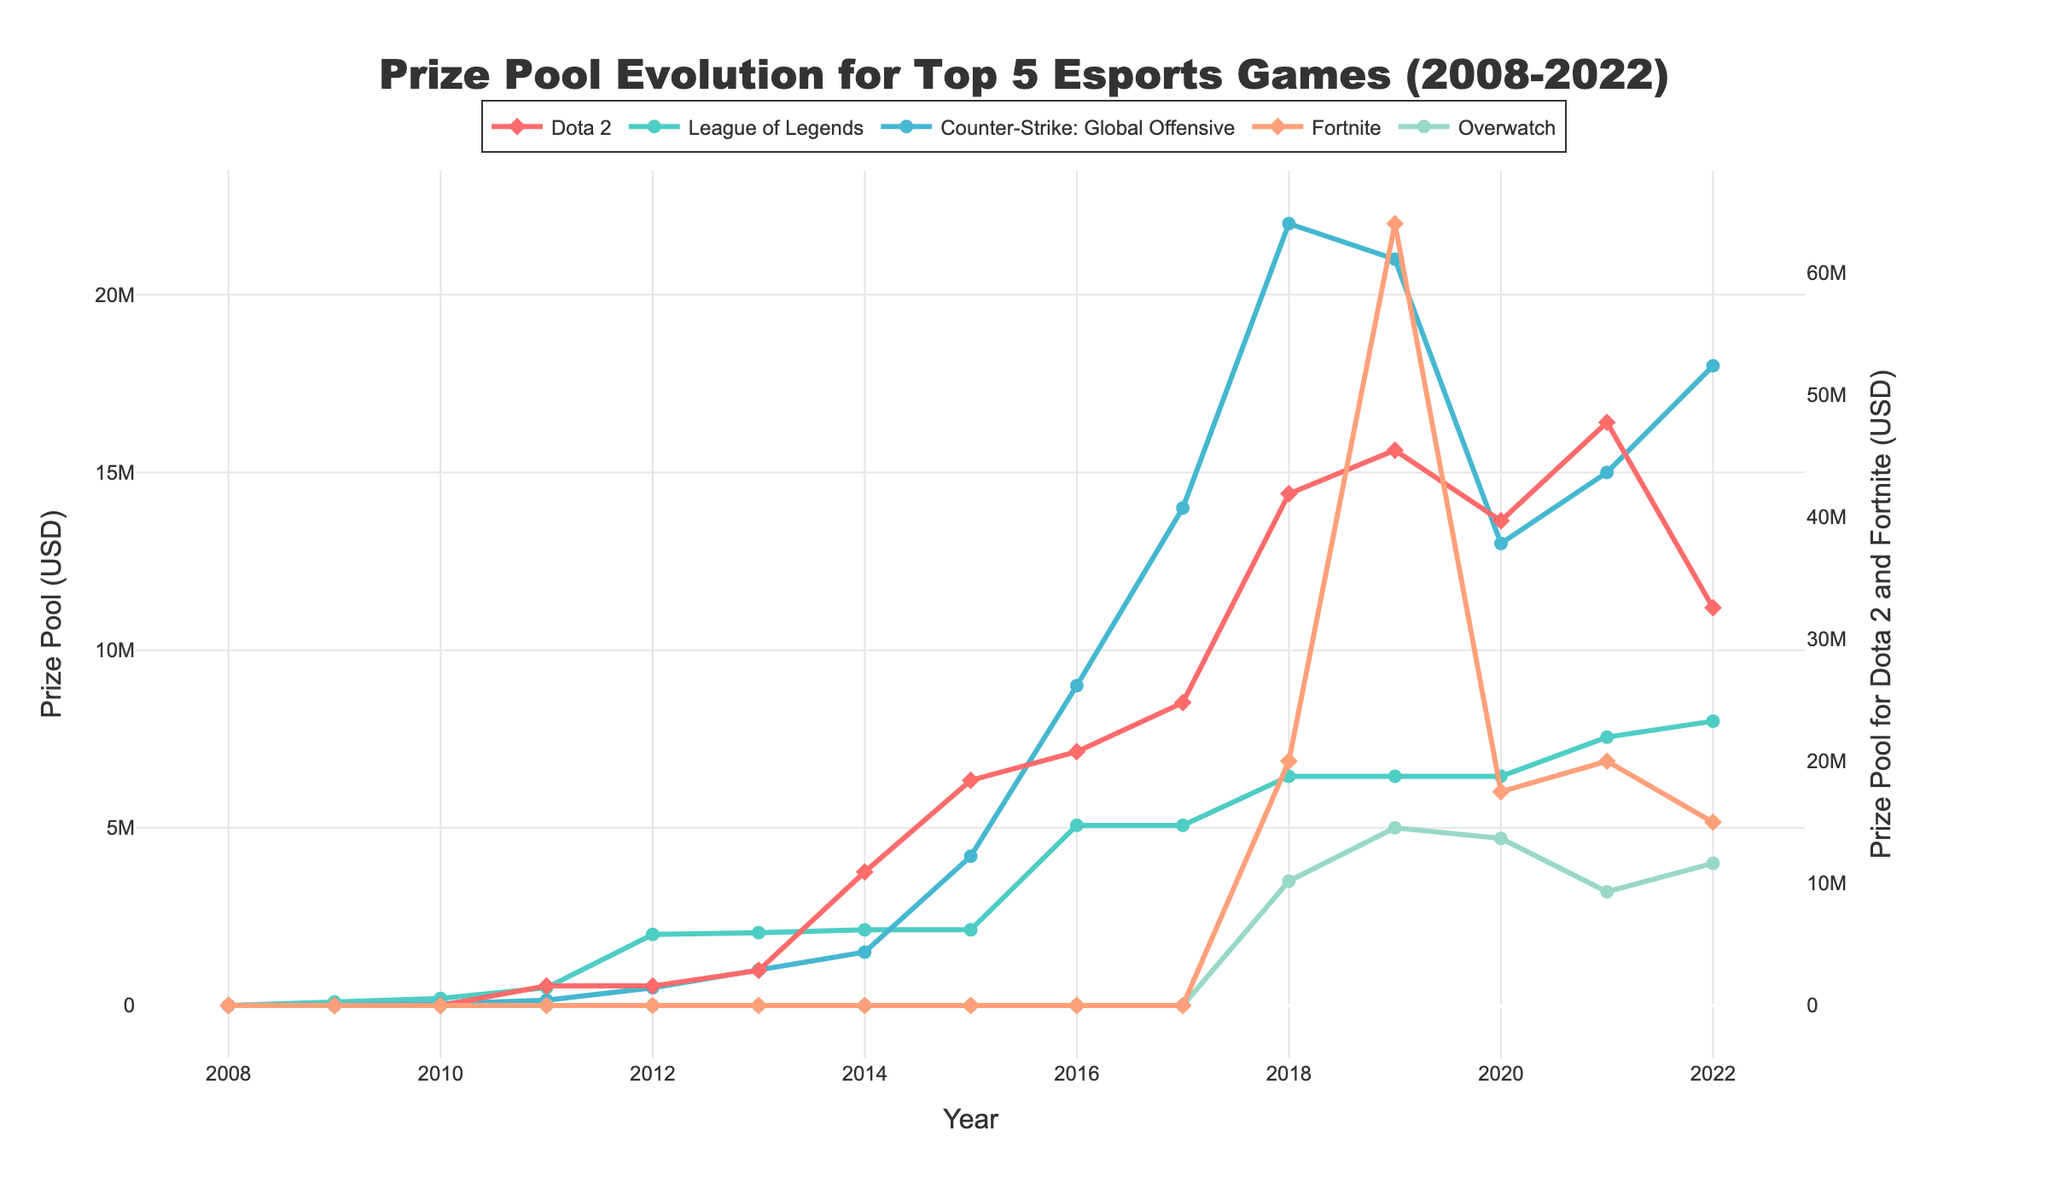What is the trend in the prize pool for Dota 2 over the years? To determine the trend, observe the line representing Dota 2 on the graph from 2008 to 2022. The prize pool for Dota 2 shows a general increasing trend from 2011, with several peaks in 2014, 2018, 2019, and 2021.
Answer: Increasing Which game had the highest prize pool in 2018? Identify the lines for each game in 2018. Fortnite had the tallest point on the chart in 2018, indicating it had the highest prize pool.
Answer: Fortnite What was the total prize pool for Counter-Strike: Global Offensive and Fortnite in 2019? Sum the prize pool for Counter-Strike: Global Offensive and Fortnite in 2019. This is 21,000,000 + 64,000,000 = 85,000,000.
Answer: 85,000,000 Between 2011 and 2014, which game had the most consistent prize pool value? Observe the lines for each game between 2011 and 2014. League of Legends shows the least variation in prize pool values, remaining around 2,130,000.
Answer: League of Legends How did the prize pool for Overwatch change from 2018 to 2022? Trace the line for Overwatch from 2018 to 2022. It starts at 3,500,000 in 2018, increases to 5,000,000 in 2019, drops to 4,700,000 in 2020, further drops to 3,200,000 in 2021, and rises again to 4,000,000 in 2022.
Answer: Varied Which two games showed significant prize pool increases in 2018? Look for lines that have a significant jump going into 2018. Both Dota 2 and Fortnite experienced substantial increases in their prize pools in 2018.
Answer: Dota 2, Fortnite What was the difference in prize pool between Dota 2 and League of Legends in 2021? Subtract the prize pool for League of Legends from Dota 2 in 2021. This is 47,730,320 - 7,550,000 = 40,180,320.
Answer: 40,180,320 Which year saw the introduction of Fortnite in the prize pool data? Locate the first appearance of Fortnite on the chart. Fortnite appears for the first time in 2018.
Answer: 2018 What was the average prize pool for League of Legends from 2016 to 2022? Average the prize pool for League of Legends from 2016 to 2022: (5,070,000 + 5,070,000 + 6,450,000 + 6,450,000 + 6,450,000 + 7,550,000 + 8,000,000) / 7 = 6,434,285.71.
Answer: 6,434,285.71 